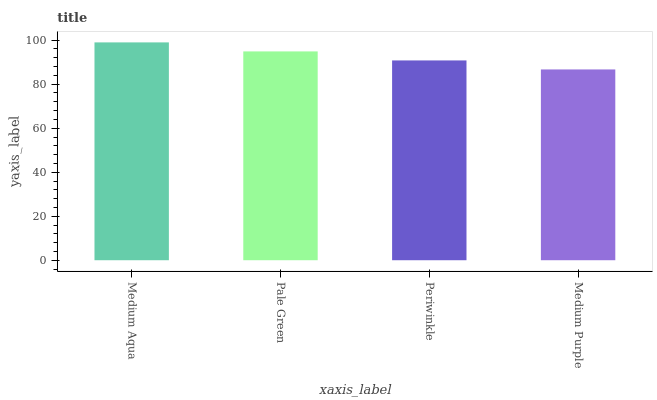Is Medium Purple the minimum?
Answer yes or no. Yes. Is Medium Aqua the maximum?
Answer yes or no. Yes. Is Pale Green the minimum?
Answer yes or no. No. Is Pale Green the maximum?
Answer yes or no. No. Is Medium Aqua greater than Pale Green?
Answer yes or no. Yes. Is Pale Green less than Medium Aqua?
Answer yes or no. Yes. Is Pale Green greater than Medium Aqua?
Answer yes or no. No. Is Medium Aqua less than Pale Green?
Answer yes or no. No. Is Pale Green the high median?
Answer yes or no. Yes. Is Periwinkle the low median?
Answer yes or no. Yes. Is Medium Aqua the high median?
Answer yes or no. No. Is Medium Purple the low median?
Answer yes or no. No. 